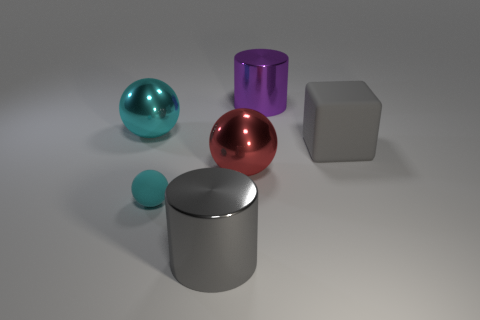What shape is the other object that is the same color as the tiny rubber object?
Provide a succinct answer. Sphere. There is a metallic cylinder on the right side of the big cylinder that is left of the red shiny ball; how big is it?
Provide a succinct answer. Large. Are there any other things that have the same color as the small matte thing?
Provide a short and direct response. Yes. Are the large gray thing that is to the left of the big purple thing and the gray thing that is to the right of the large purple cylinder made of the same material?
Keep it short and to the point. No. What is the material of the thing that is behind the large gray matte block and in front of the big purple object?
Make the answer very short. Metal. Does the red metal thing have the same shape as the cyan object in front of the big cube?
Give a very brief answer. Yes. There is a gray thing right of the gray thing on the left side of the big cylinder right of the big red ball; what is it made of?
Provide a succinct answer. Rubber. What number of other things are there of the same size as the gray shiny thing?
Make the answer very short. 4. Is the tiny object the same color as the matte block?
Your response must be concise. No. What number of rubber things are behind the big metallic thing that is behind the big sphere to the left of the big red sphere?
Your answer should be compact. 0. 